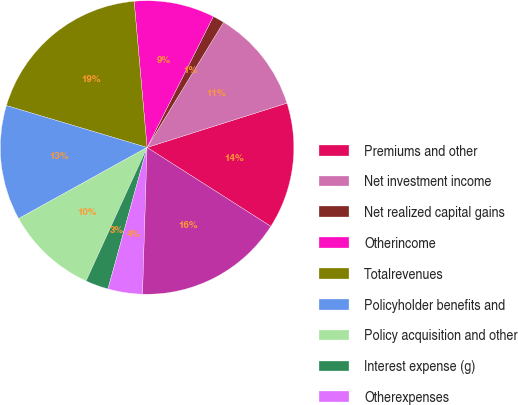Convert chart to OTSL. <chart><loc_0><loc_0><loc_500><loc_500><pie_chart><fcel>Premiums and other<fcel>Net investment income<fcel>Net realized capital gains<fcel>Otherincome<fcel>Totalrevenues<fcel>Policyholder benefits and<fcel>Policy acquisition and other<fcel>Interest expense (g)<fcel>Otherexpenses<fcel>Total benefits claims and<nl><fcel>13.92%<fcel>11.39%<fcel>1.27%<fcel>8.86%<fcel>18.99%<fcel>12.66%<fcel>10.13%<fcel>2.53%<fcel>3.8%<fcel>16.46%<nl></chart> 